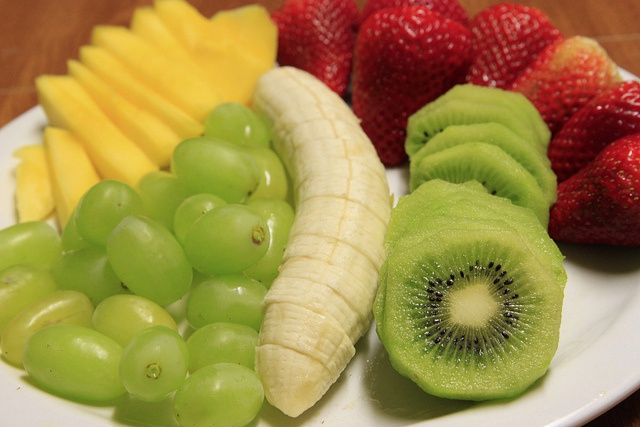Describe the objects in this image and their specific colors. I can see banana in brown and tan tones, banana in brown and gold tones, and dining table in brown and tan tones in this image. 